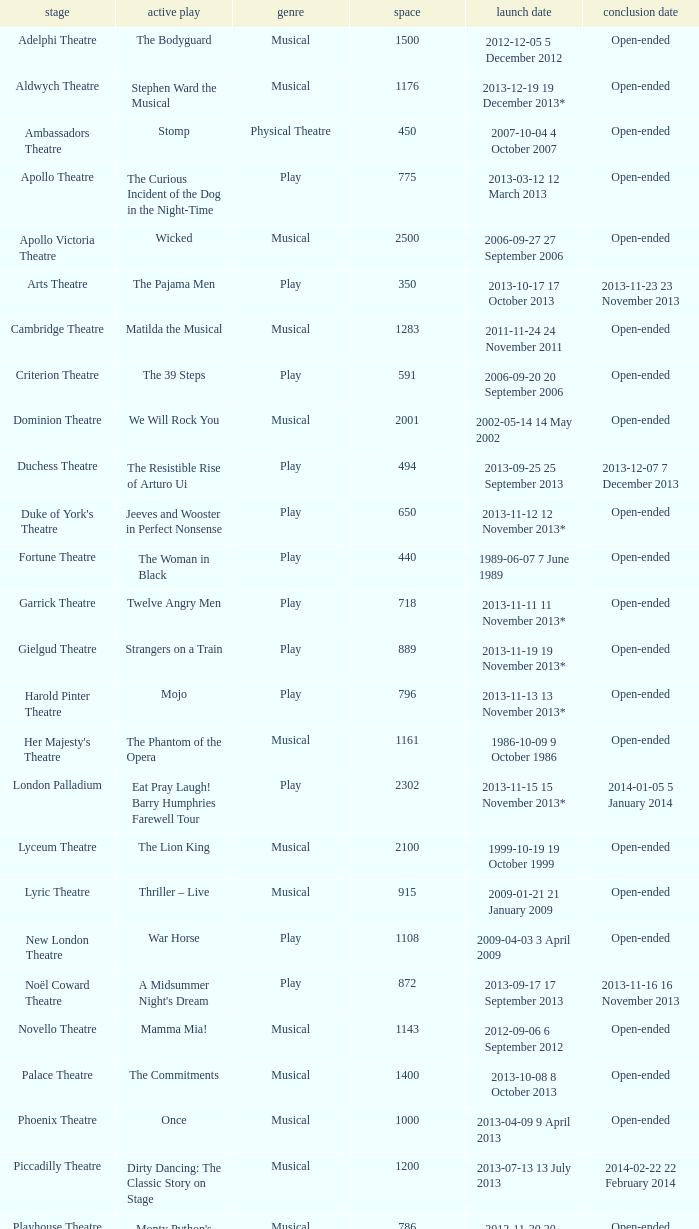Give me the full table as a dictionary. {'header': ['stage', 'active play', 'genre', 'space', 'launch date', 'conclusion date'], 'rows': [['Adelphi Theatre', 'The Bodyguard', 'Musical', '1500', '2012-12-05 5 December 2012', 'Open-ended'], ['Aldwych Theatre', 'Stephen Ward the Musical', 'Musical', '1176', '2013-12-19 19 December 2013*', 'Open-ended'], ['Ambassadors Theatre', 'Stomp', 'Physical Theatre', '450', '2007-10-04 4 October 2007', 'Open-ended'], ['Apollo Theatre', 'The Curious Incident of the Dog in the Night-Time', 'Play', '775', '2013-03-12 12 March 2013', 'Open-ended'], ['Apollo Victoria Theatre', 'Wicked', 'Musical', '2500', '2006-09-27 27 September 2006', 'Open-ended'], ['Arts Theatre', 'The Pajama Men', 'Play', '350', '2013-10-17 17 October 2013', '2013-11-23 23 November 2013'], ['Cambridge Theatre', 'Matilda the Musical', 'Musical', '1283', '2011-11-24 24 November 2011', 'Open-ended'], ['Criterion Theatre', 'The 39 Steps', 'Play', '591', '2006-09-20 20 September 2006', 'Open-ended'], ['Dominion Theatre', 'We Will Rock You', 'Musical', '2001', '2002-05-14 14 May 2002', 'Open-ended'], ['Duchess Theatre', 'The Resistible Rise of Arturo Ui', 'Play', '494', '2013-09-25 25 September 2013', '2013-12-07 7 December 2013'], ["Duke of York's Theatre", 'Jeeves and Wooster in Perfect Nonsense', 'Play', '650', '2013-11-12 12 November 2013*', 'Open-ended'], ['Fortune Theatre', 'The Woman in Black', 'Play', '440', '1989-06-07 7 June 1989', 'Open-ended'], ['Garrick Theatre', 'Twelve Angry Men', 'Play', '718', '2013-11-11 11 November 2013*', 'Open-ended'], ['Gielgud Theatre', 'Strangers on a Train', 'Play', '889', '2013-11-19 19 November 2013*', 'Open-ended'], ['Harold Pinter Theatre', 'Mojo', 'Play', '796', '2013-11-13 13 November 2013*', 'Open-ended'], ["Her Majesty's Theatre", 'The Phantom of the Opera', 'Musical', '1161', '1986-10-09 9 October 1986', 'Open-ended'], ['London Palladium', 'Eat Pray Laugh! Barry Humphries Farewell Tour', 'Play', '2302', '2013-11-15 15 November 2013*', '2014-01-05 5 January 2014'], ['Lyceum Theatre', 'The Lion King', 'Musical', '2100', '1999-10-19 19 October 1999', 'Open-ended'], ['Lyric Theatre', 'Thriller – Live', 'Musical', '915', '2009-01-21 21 January 2009', 'Open-ended'], ['New London Theatre', 'War Horse', 'Play', '1108', '2009-04-03 3 April 2009', 'Open-ended'], ['Noël Coward Theatre', "A Midsummer Night's Dream", 'Play', '872', '2013-09-17 17 September 2013', '2013-11-16 16 November 2013'], ['Novello Theatre', 'Mamma Mia!', 'Musical', '1143', '2012-09-06 6 September 2012', 'Open-ended'], ['Palace Theatre', 'The Commitments', 'Musical', '1400', '2013-10-08 8 October 2013', 'Open-ended'], ['Phoenix Theatre', 'Once', 'Musical', '1000', '2013-04-09 9 April 2013', 'Open-ended'], ['Piccadilly Theatre', 'Dirty Dancing: The Classic Story on Stage', 'Musical', '1200', '2013-07-13 13 July 2013', '2014-02-22 22 February 2014'], ['Playhouse Theatre', "Monty Python's Spamalot", 'Musical', '786', '2012-11-20 20 November 2012', 'Open-ended'], ['Prince Edward Theatre', 'Jersey Boys', 'Musical', '1618', '2008-03-18 18 March 2008', '2014-03-09 9 March 2014'], ['Prince of Wales Theatre', 'The Book of Mormon', 'Musical', '1160', '2013-03-21 21 March 2013', 'Open-ended'], ["Queen's Theatre", 'Les Misérables', 'Musical', '1099', '2004-04-12 12 April 2004', 'Open-ended'], ['Savoy Theatre', 'Let It Be', 'Musical', '1158', '2013-02-01 1 February 2013', 'Open-ended'], ['Shaftesbury Theatre', 'From Here to Eternity the Musical', 'Musical', '1400', '2013-10-23 23 October 2013', 'Open-ended'], ['St. James Theatre', 'Scenes from a Marriage', 'Play', '312', '2013-09-11 11 September 2013', '2013-11-9 9 November 2013'], ["St Martin's Theatre", 'The Mousetrap', 'Play', '550', '1974-03-25 25 March 1974', 'Open-ended'], ['Theatre Royal, Haymarket', 'One Man, Two Guvnors', 'Play', '888', '2012-03-02 2 March 2012', '2013-03-01 1 March 2014'], ['Theatre Royal, Drury Lane', 'Charlie and the Chocolate Factory the Musical', 'Musical', '2220', '2013-06-25 25 June 2013', 'Open-ended'], ['Trafalgar Studios 1', 'The Pride', 'Play', '380', '2013-08-13 13 August 2013', '2013-11-23 23 November 2013'], ['Trafalgar Studios 2', 'Mrs. Lowry and Son', 'Play', '100', '2013-11-01 1 November 2013', '2013-11-23 23 November 2013'], ['Vaudeville Theatre', 'The Ladykillers', 'Play', '681', '2013-07-09 9 July 2013', '2013-11-16 16 November 2013'], ['Victoria Palace Theatre', 'Billy Elliot the Musical', 'Musical', '1517', '2005-05-11 11 May 2005', 'Open-ended'], ["Wyndham's Theatre", 'Barking in Essex', 'Play', '750', '2013-09-16 16 September 2013', '2014-01-04 4 January 2014']]} What is the opening date of the musical at the adelphi theatre? 2012-12-05 5 December 2012. 